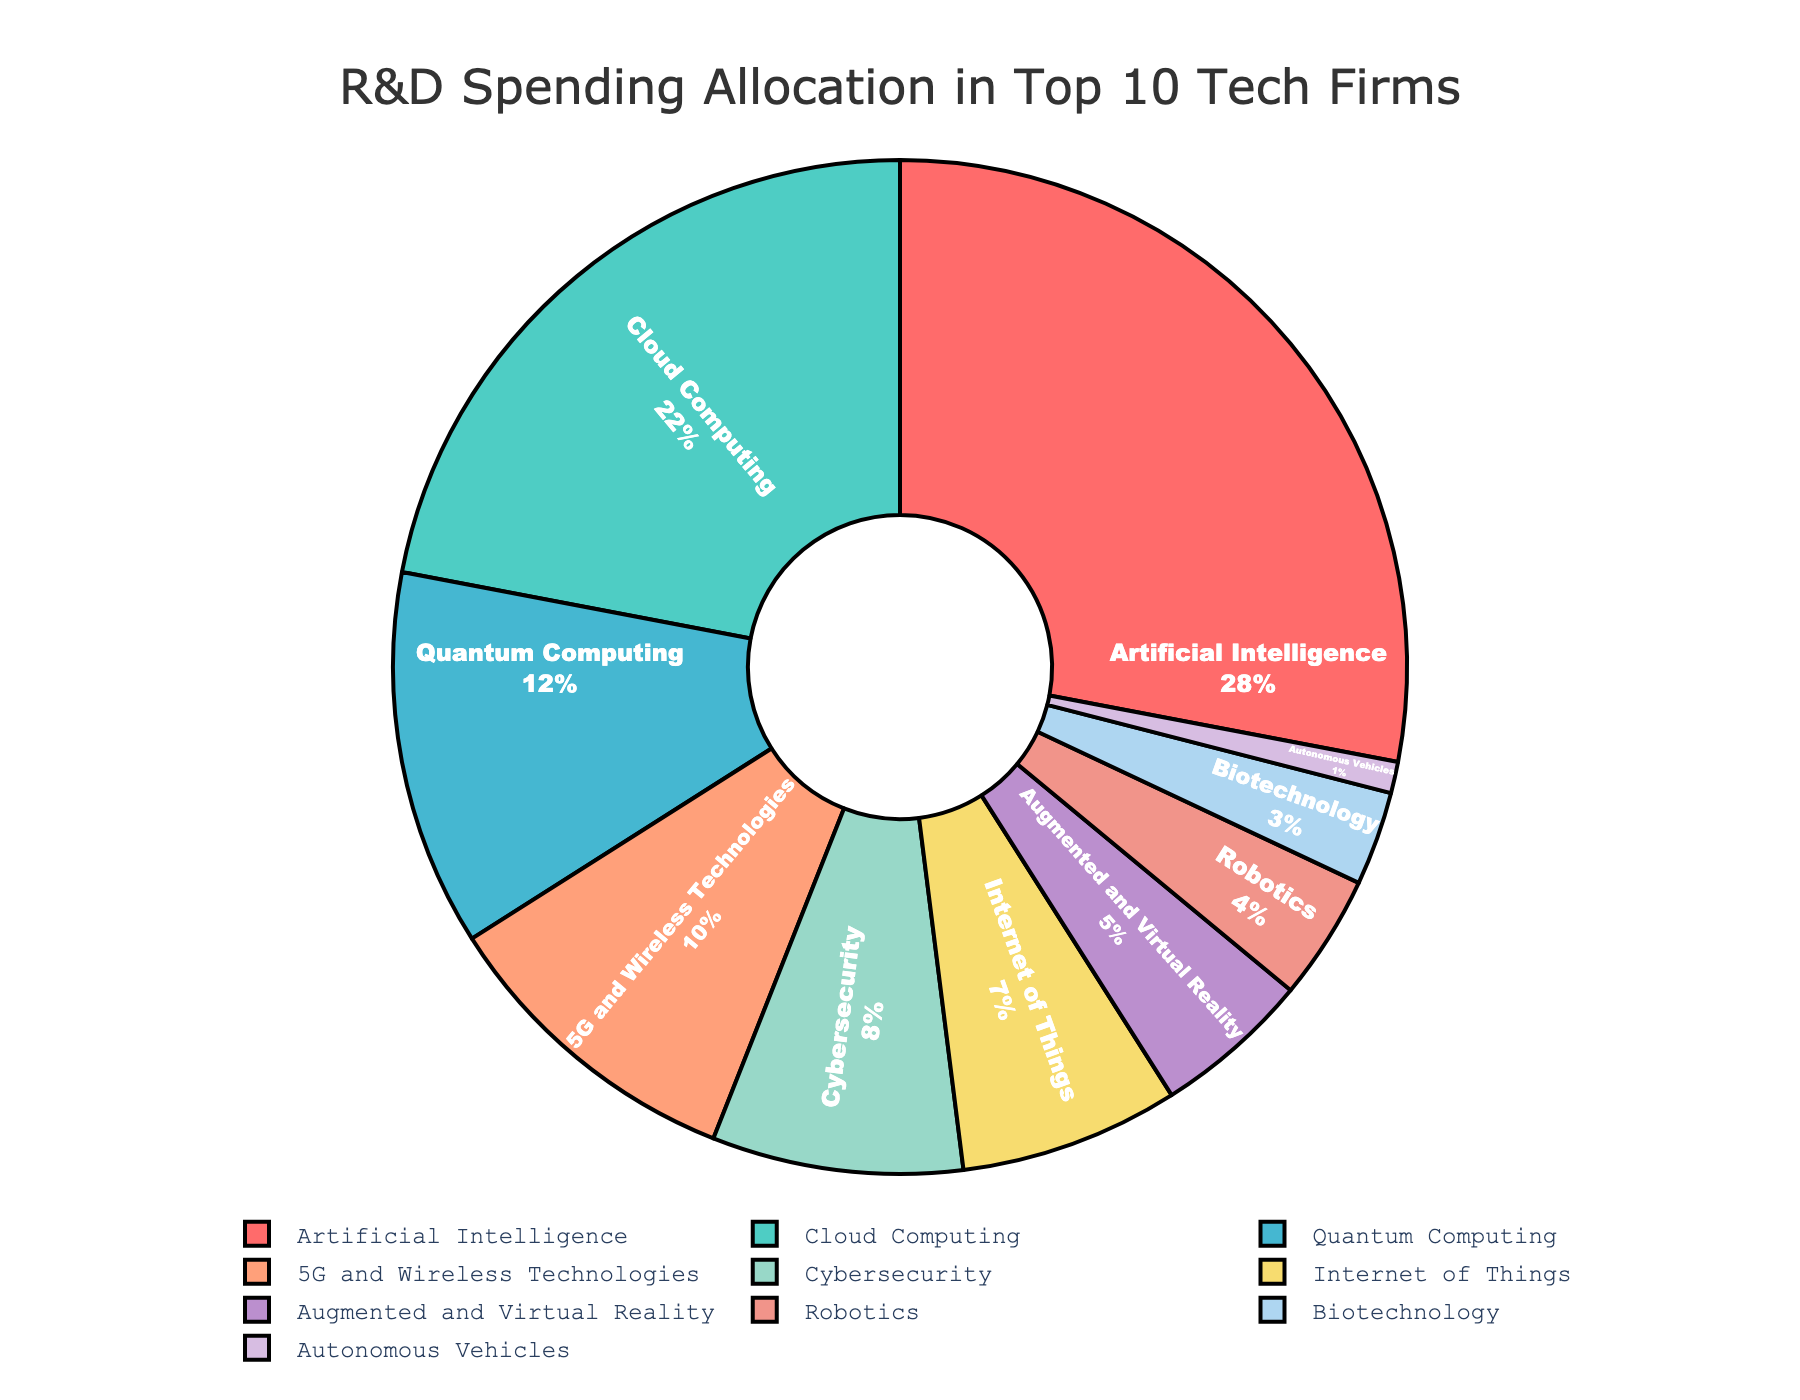What percentage of the R&D spending is allocated to Artificial Intelligence and Cloud Computing combined? To find the combined percentage, sum the individual percentages for Artificial Intelligence and Cloud Computing. Artificial Intelligence contributes 28% and Cloud Computing contributes 22%, so the total is 28% + 22% = 50%.
Answer: 50% Which category has a higher R&D spending allocation, Internet of Things or Cybersecurity? Compare the percentages for Internet of Things and Cybersecurity. Internet of Things has 7% and Cybersecurity has 8%. Since 8% is greater than 7%, Cybersecurity has a higher allocation.
Answer: Cybersecurity What is the visual appearance of the sector representing Quantum Computing in terms of color? According to the color palette list and the order of categories, Quantum Computing is represented by the third color in the list, which is a shade of blue.
Answer: Blue If we sum the R&D spending percentages for 5G and Wireless Technologies, Augmented and Virtual Reality, and Robotics, what is the total percentage? Add the individual percentages for 5G and Wireless Technologies (10%), Augmented and Virtual Reality (5%), and Robotics (4%). The total is 10% + 5% + 4% = 19%.
Answer: 19% Which category has the least R&D spending allocation, and what is its percentage? Look for the smallest percentage in the list. Autonomous Vehicles have the lowest allocation with 1%.
Answer: Autonomous Vehicles, 1% What is the difference in R&D spending between Artificial Intelligence and Quantum Computing? Subtract the percentage for Quantum Computing from the percentage for Artificial Intelligence. Artificial Intelligence has 28% and Quantum Computing has 12%, so the difference is 28% - 12% = 16%.
Answer: 16% Identify the category with the second highest R&D spending and state its percentage. Based on the percentage values, Cloud Computing has the second highest allocation, with 22%.
Answer: Cloud Computing, 22% What percentage of the total R&D spending is allocated to categories with less than 10% allocation each? Categories with less than 10% allocation are Quantum Computing (12%), 5G and Wireless Technologies (10%), Cybersecurity (8%), Internet of Things (7%), Augmented and Virtual Reality (5%), Robotics (4%), Biotechnology (3%), and Autonomous Vehicles (1%). Sum these percentages: 10% + 8% + 7% + 5% + 4% + 3% + 1% = 38%.
Answer: 38% Which category is represented by the orange color in the pie chart? Referring to the color scheme and the order of categories, 5G and Wireless Technologies is represented by the orange color.
Answer: 5G and Wireless Technologies 